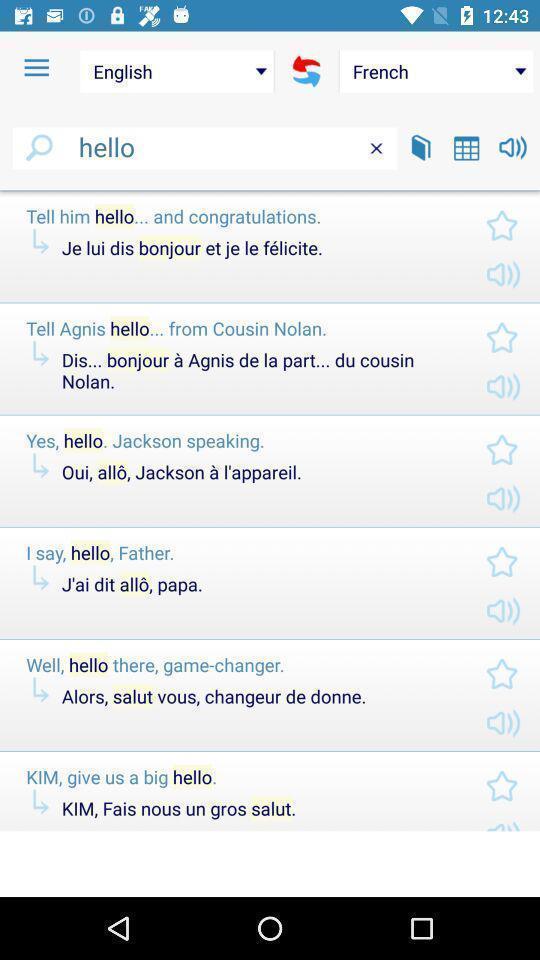Summarize the main components in this picture. Screen displaying page of an translator application. 